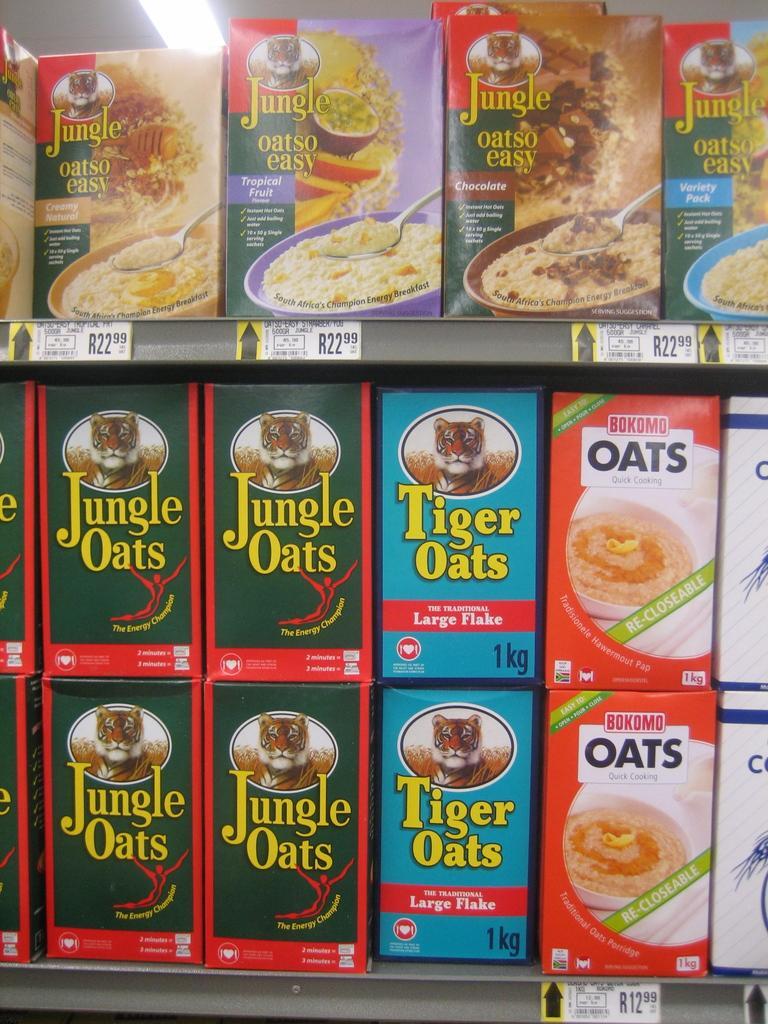Can you describe this image briefly? In this image there are boxes with some text and images on it and there is a light on the top. 